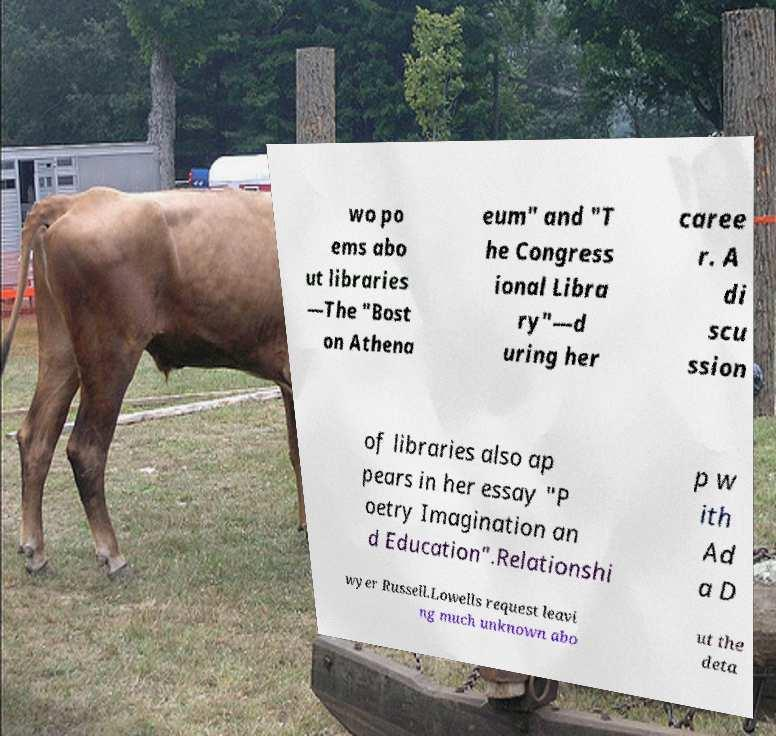Could you assist in decoding the text presented in this image and type it out clearly? wo po ems abo ut libraries —The "Bost on Athena eum" and "T he Congress ional Libra ry"—d uring her caree r. A di scu ssion of libraries also ap pears in her essay "P oetry Imagination an d Education".Relationshi p w ith Ad a D wyer Russell.Lowells request leavi ng much unknown abo ut the deta 